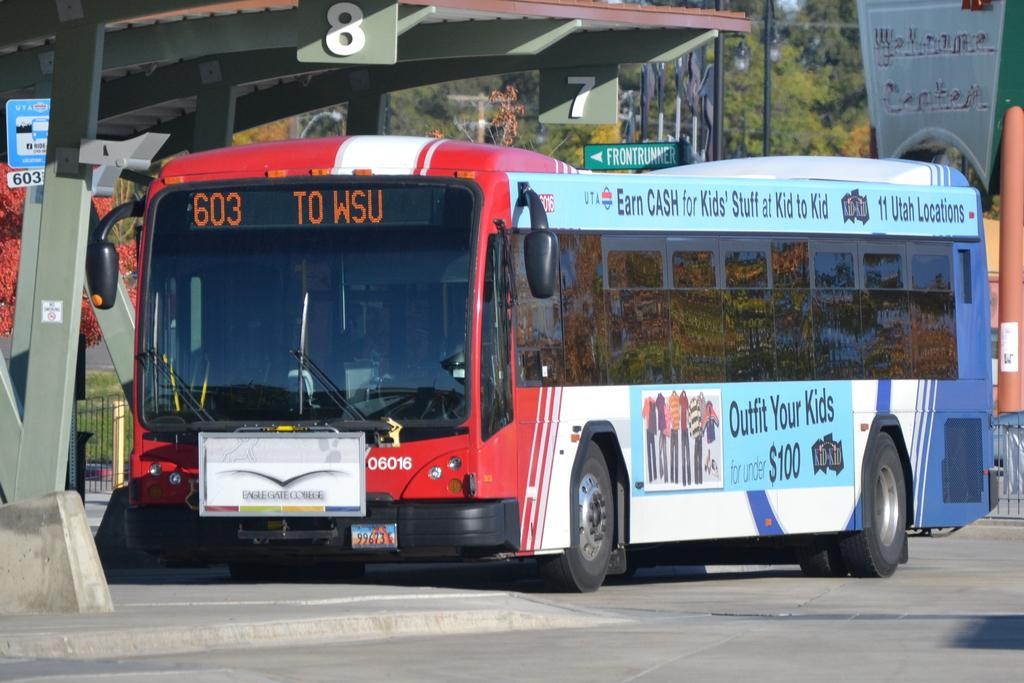What is the main subject of the image? There is a bus in the image. What can be seen beside the bus? There are sign boards and a shelter beside the bus. What is visible in the background of the image? There are metal rods and trees in the background of the image. Can you see any fish being used as bait in the image? There is no fish or bait present in the image. How many times does the bus jump in the image? Buses do not jump, so this question cannot be answered based on the image. 